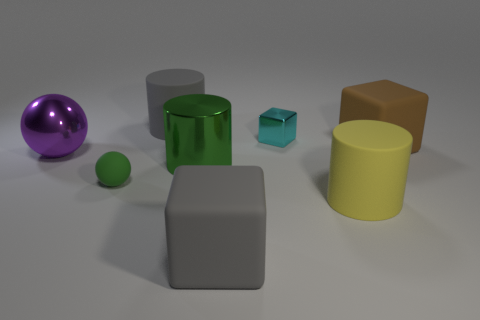There is a rubber cube behind the gray matte cube; is it the same color as the tiny metallic thing behind the tiny green rubber thing? no 